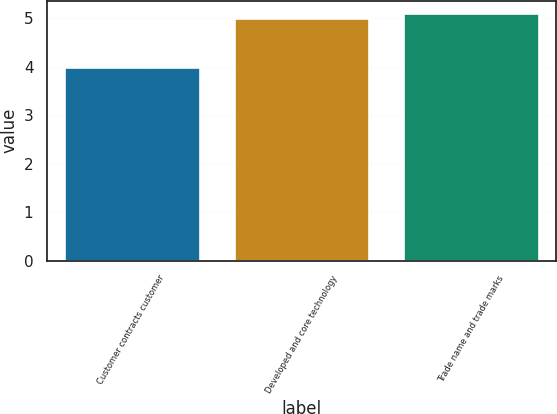Convert chart to OTSL. <chart><loc_0><loc_0><loc_500><loc_500><bar_chart><fcel>Customer contracts customer<fcel>Developed and core technology<fcel>Trade name and trade marks<nl><fcel>4<fcel>5<fcel>5.1<nl></chart> 